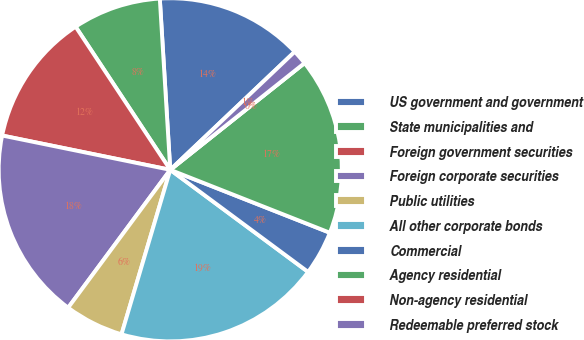Convert chart. <chart><loc_0><loc_0><loc_500><loc_500><pie_chart><fcel>US government and government<fcel>State municipalities and<fcel>Foreign government securities<fcel>Foreign corporate securities<fcel>Public utilities<fcel>All other corporate bonds<fcel>Commercial<fcel>Agency residential<fcel>Non-agency residential<fcel>Redeemable preferred stock<nl><fcel>13.89%<fcel>8.33%<fcel>12.5%<fcel>18.06%<fcel>5.56%<fcel>19.44%<fcel>4.17%<fcel>16.67%<fcel>0.0%<fcel>1.39%<nl></chart> 